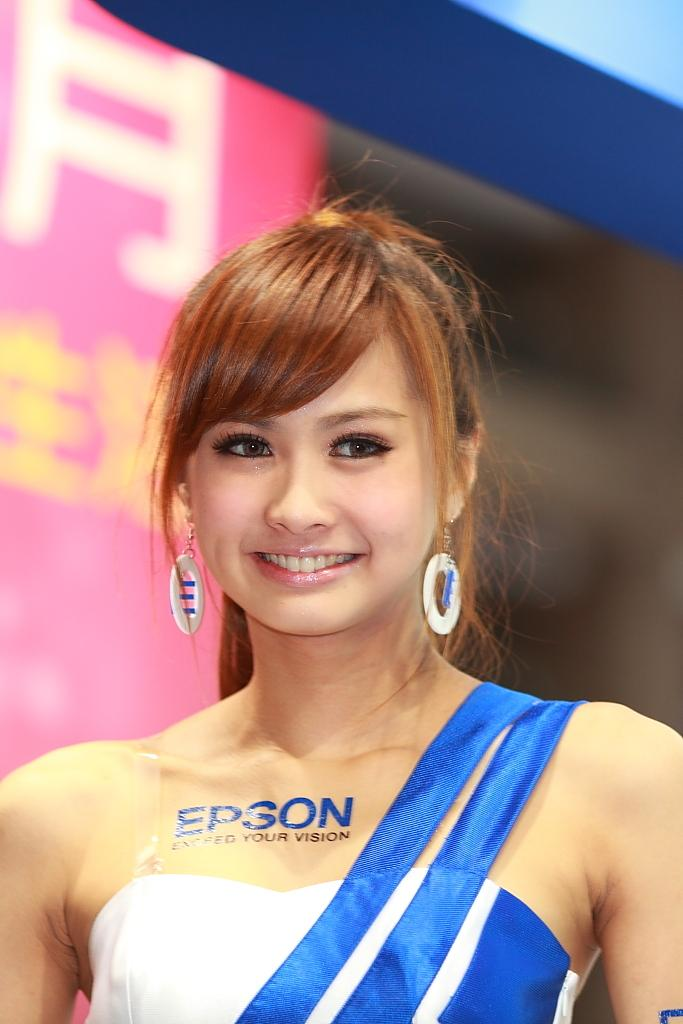<image>
Offer a succinct explanation of the picture presented. A woman in a blue and white dress, with the company name Epson on her chest, is smiling for a photo shoot. 